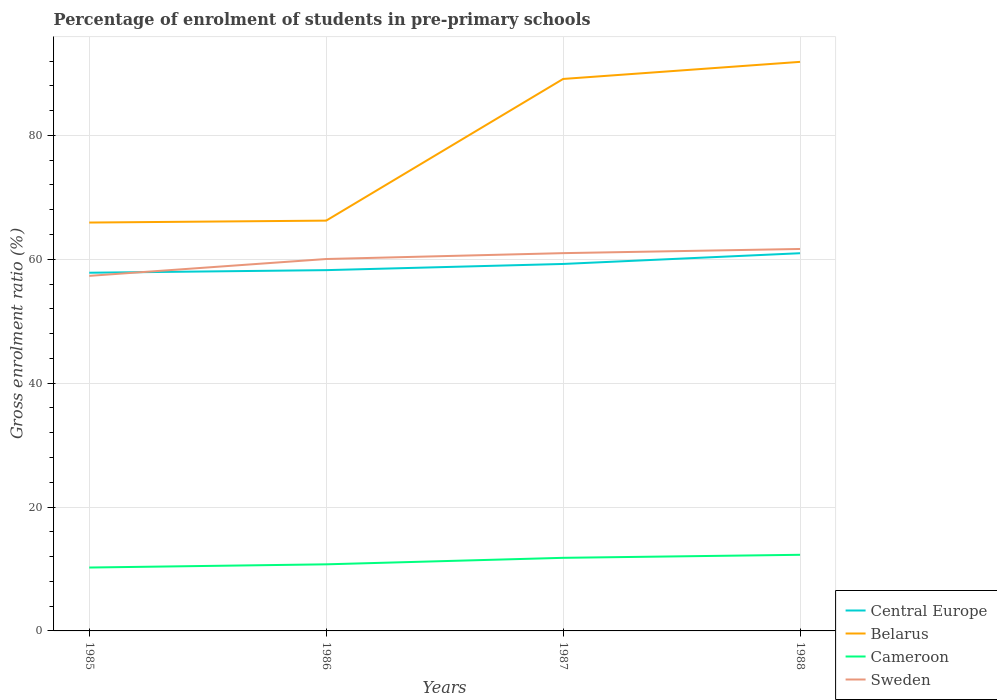How many different coloured lines are there?
Ensure brevity in your answer.  4. Does the line corresponding to Sweden intersect with the line corresponding to Cameroon?
Your answer should be compact. No. Is the number of lines equal to the number of legend labels?
Offer a very short reply. Yes. Across all years, what is the maximum percentage of students enrolled in pre-primary schools in Central Europe?
Your answer should be compact. 57.83. In which year was the percentage of students enrolled in pre-primary schools in Cameroon maximum?
Your answer should be compact. 1985. What is the total percentage of students enrolled in pre-primary schools in Cameroon in the graph?
Ensure brevity in your answer.  -1.54. What is the difference between the highest and the second highest percentage of students enrolled in pre-primary schools in Cameroon?
Keep it short and to the point. 2.06. What is the difference between the highest and the lowest percentage of students enrolled in pre-primary schools in Cameroon?
Give a very brief answer. 2. Is the percentage of students enrolled in pre-primary schools in Belarus strictly greater than the percentage of students enrolled in pre-primary schools in Sweden over the years?
Your answer should be very brief. No. How many years are there in the graph?
Offer a terse response. 4. What is the difference between two consecutive major ticks on the Y-axis?
Provide a succinct answer. 20. Does the graph contain any zero values?
Your answer should be very brief. No. How many legend labels are there?
Give a very brief answer. 4. How are the legend labels stacked?
Your response must be concise. Vertical. What is the title of the graph?
Your answer should be compact. Percentage of enrolment of students in pre-primary schools. Does "Japan" appear as one of the legend labels in the graph?
Ensure brevity in your answer.  No. What is the label or title of the X-axis?
Your answer should be compact. Years. What is the label or title of the Y-axis?
Provide a succinct answer. Gross enrolment ratio (%). What is the Gross enrolment ratio (%) in Central Europe in 1985?
Make the answer very short. 57.83. What is the Gross enrolment ratio (%) in Belarus in 1985?
Your answer should be very brief. 65.93. What is the Gross enrolment ratio (%) in Cameroon in 1985?
Provide a short and direct response. 10.23. What is the Gross enrolment ratio (%) of Sweden in 1985?
Ensure brevity in your answer.  57.32. What is the Gross enrolment ratio (%) in Central Europe in 1986?
Provide a short and direct response. 58.25. What is the Gross enrolment ratio (%) of Belarus in 1986?
Your response must be concise. 66.24. What is the Gross enrolment ratio (%) in Cameroon in 1986?
Your answer should be compact. 10.75. What is the Gross enrolment ratio (%) of Sweden in 1986?
Keep it short and to the point. 60.04. What is the Gross enrolment ratio (%) of Central Europe in 1987?
Your answer should be compact. 59.25. What is the Gross enrolment ratio (%) of Belarus in 1987?
Provide a succinct answer. 89.12. What is the Gross enrolment ratio (%) of Cameroon in 1987?
Make the answer very short. 11.8. What is the Gross enrolment ratio (%) of Sweden in 1987?
Provide a succinct answer. 60.99. What is the Gross enrolment ratio (%) of Central Europe in 1988?
Your answer should be compact. 60.98. What is the Gross enrolment ratio (%) in Belarus in 1988?
Give a very brief answer. 91.87. What is the Gross enrolment ratio (%) in Cameroon in 1988?
Your answer should be very brief. 12.29. What is the Gross enrolment ratio (%) in Sweden in 1988?
Your answer should be very brief. 61.67. Across all years, what is the maximum Gross enrolment ratio (%) of Central Europe?
Ensure brevity in your answer.  60.98. Across all years, what is the maximum Gross enrolment ratio (%) in Belarus?
Ensure brevity in your answer.  91.87. Across all years, what is the maximum Gross enrolment ratio (%) in Cameroon?
Ensure brevity in your answer.  12.29. Across all years, what is the maximum Gross enrolment ratio (%) in Sweden?
Make the answer very short. 61.67. Across all years, what is the minimum Gross enrolment ratio (%) of Central Europe?
Your answer should be very brief. 57.83. Across all years, what is the minimum Gross enrolment ratio (%) in Belarus?
Your response must be concise. 65.93. Across all years, what is the minimum Gross enrolment ratio (%) in Cameroon?
Provide a short and direct response. 10.23. Across all years, what is the minimum Gross enrolment ratio (%) of Sweden?
Your answer should be compact. 57.32. What is the total Gross enrolment ratio (%) of Central Europe in the graph?
Keep it short and to the point. 236.3. What is the total Gross enrolment ratio (%) in Belarus in the graph?
Provide a succinct answer. 313.16. What is the total Gross enrolment ratio (%) in Cameroon in the graph?
Ensure brevity in your answer.  45.08. What is the total Gross enrolment ratio (%) in Sweden in the graph?
Provide a succinct answer. 240.02. What is the difference between the Gross enrolment ratio (%) in Central Europe in 1985 and that in 1986?
Your answer should be very brief. -0.42. What is the difference between the Gross enrolment ratio (%) of Belarus in 1985 and that in 1986?
Provide a short and direct response. -0.31. What is the difference between the Gross enrolment ratio (%) in Cameroon in 1985 and that in 1986?
Make the answer very short. -0.52. What is the difference between the Gross enrolment ratio (%) of Sweden in 1985 and that in 1986?
Give a very brief answer. -2.72. What is the difference between the Gross enrolment ratio (%) in Central Europe in 1985 and that in 1987?
Your answer should be very brief. -1.42. What is the difference between the Gross enrolment ratio (%) of Belarus in 1985 and that in 1987?
Your answer should be very brief. -23.18. What is the difference between the Gross enrolment ratio (%) of Cameroon in 1985 and that in 1987?
Offer a very short reply. -1.57. What is the difference between the Gross enrolment ratio (%) of Sweden in 1985 and that in 1987?
Provide a succinct answer. -3.67. What is the difference between the Gross enrolment ratio (%) in Central Europe in 1985 and that in 1988?
Make the answer very short. -3.15. What is the difference between the Gross enrolment ratio (%) of Belarus in 1985 and that in 1988?
Give a very brief answer. -25.94. What is the difference between the Gross enrolment ratio (%) of Cameroon in 1985 and that in 1988?
Your answer should be very brief. -2.06. What is the difference between the Gross enrolment ratio (%) in Sweden in 1985 and that in 1988?
Make the answer very short. -4.34. What is the difference between the Gross enrolment ratio (%) in Central Europe in 1986 and that in 1987?
Offer a very short reply. -1. What is the difference between the Gross enrolment ratio (%) in Belarus in 1986 and that in 1987?
Give a very brief answer. -22.87. What is the difference between the Gross enrolment ratio (%) in Cameroon in 1986 and that in 1987?
Make the answer very short. -1.05. What is the difference between the Gross enrolment ratio (%) of Sweden in 1986 and that in 1987?
Ensure brevity in your answer.  -0.95. What is the difference between the Gross enrolment ratio (%) in Central Europe in 1986 and that in 1988?
Offer a terse response. -2.73. What is the difference between the Gross enrolment ratio (%) of Belarus in 1986 and that in 1988?
Make the answer very short. -25.63. What is the difference between the Gross enrolment ratio (%) of Cameroon in 1986 and that in 1988?
Make the answer very short. -1.54. What is the difference between the Gross enrolment ratio (%) of Sweden in 1986 and that in 1988?
Give a very brief answer. -1.62. What is the difference between the Gross enrolment ratio (%) of Central Europe in 1987 and that in 1988?
Provide a short and direct response. -1.73. What is the difference between the Gross enrolment ratio (%) in Belarus in 1987 and that in 1988?
Your answer should be compact. -2.76. What is the difference between the Gross enrolment ratio (%) of Cameroon in 1987 and that in 1988?
Offer a terse response. -0.49. What is the difference between the Gross enrolment ratio (%) of Sweden in 1987 and that in 1988?
Offer a very short reply. -0.67. What is the difference between the Gross enrolment ratio (%) of Central Europe in 1985 and the Gross enrolment ratio (%) of Belarus in 1986?
Make the answer very short. -8.41. What is the difference between the Gross enrolment ratio (%) of Central Europe in 1985 and the Gross enrolment ratio (%) of Cameroon in 1986?
Your answer should be compact. 47.08. What is the difference between the Gross enrolment ratio (%) of Central Europe in 1985 and the Gross enrolment ratio (%) of Sweden in 1986?
Offer a very short reply. -2.21. What is the difference between the Gross enrolment ratio (%) of Belarus in 1985 and the Gross enrolment ratio (%) of Cameroon in 1986?
Make the answer very short. 55.18. What is the difference between the Gross enrolment ratio (%) in Belarus in 1985 and the Gross enrolment ratio (%) in Sweden in 1986?
Offer a terse response. 5.89. What is the difference between the Gross enrolment ratio (%) of Cameroon in 1985 and the Gross enrolment ratio (%) of Sweden in 1986?
Offer a terse response. -49.81. What is the difference between the Gross enrolment ratio (%) in Central Europe in 1985 and the Gross enrolment ratio (%) in Belarus in 1987?
Provide a succinct answer. -31.29. What is the difference between the Gross enrolment ratio (%) of Central Europe in 1985 and the Gross enrolment ratio (%) of Cameroon in 1987?
Provide a short and direct response. 46.03. What is the difference between the Gross enrolment ratio (%) in Central Europe in 1985 and the Gross enrolment ratio (%) in Sweden in 1987?
Your response must be concise. -3.16. What is the difference between the Gross enrolment ratio (%) in Belarus in 1985 and the Gross enrolment ratio (%) in Cameroon in 1987?
Offer a very short reply. 54.13. What is the difference between the Gross enrolment ratio (%) in Belarus in 1985 and the Gross enrolment ratio (%) in Sweden in 1987?
Offer a very short reply. 4.94. What is the difference between the Gross enrolment ratio (%) in Cameroon in 1985 and the Gross enrolment ratio (%) in Sweden in 1987?
Offer a very short reply. -50.76. What is the difference between the Gross enrolment ratio (%) of Central Europe in 1985 and the Gross enrolment ratio (%) of Belarus in 1988?
Offer a terse response. -34.04. What is the difference between the Gross enrolment ratio (%) of Central Europe in 1985 and the Gross enrolment ratio (%) of Cameroon in 1988?
Your response must be concise. 45.54. What is the difference between the Gross enrolment ratio (%) in Central Europe in 1985 and the Gross enrolment ratio (%) in Sweden in 1988?
Provide a short and direct response. -3.84. What is the difference between the Gross enrolment ratio (%) of Belarus in 1985 and the Gross enrolment ratio (%) of Cameroon in 1988?
Give a very brief answer. 53.64. What is the difference between the Gross enrolment ratio (%) of Belarus in 1985 and the Gross enrolment ratio (%) of Sweden in 1988?
Your answer should be very brief. 4.27. What is the difference between the Gross enrolment ratio (%) in Cameroon in 1985 and the Gross enrolment ratio (%) in Sweden in 1988?
Give a very brief answer. -51.43. What is the difference between the Gross enrolment ratio (%) in Central Europe in 1986 and the Gross enrolment ratio (%) in Belarus in 1987?
Your answer should be very brief. -30.87. What is the difference between the Gross enrolment ratio (%) of Central Europe in 1986 and the Gross enrolment ratio (%) of Cameroon in 1987?
Your answer should be very brief. 46.45. What is the difference between the Gross enrolment ratio (%) of Central Europe in 1986 and the Gross enrolment ratio (%) of Sweden in 1987?
Provide a short and direct response. -2.74. What is the difference between the Gross enrolment ratio (%) in Belarus in 1986 and the Gross enrolment ratio (%) in Cameroon in 1987?
Offer a terse response. 54.44. What is the difference between the Gross enrolment ratio (%) of Belarus in 1986 and the Gross enrolment ratio (%) of Sweden in 1987?
Ensure brevity in your answer.  5.25. What is the difference between the Gross enrolment ratio (%) of Cameroon in 1986 and the Gross enrolment ratio (%) of Sweden in 1987?
Give a very brief answer. -50.24. What is the difference between the Gross enrolment ratio (%) in Central Europe in 1986 and the Gross enrolment ratio (%) in Belarus in 1988?
Offer a very short reply. -33.63. What is the difference between the Gross enrolment ratio (%) in Central Europe in 1986 and the Gross enrolment ratio (%) in Cameroon in 1988?
Your response must be concise. 45.96. What is the difference between the Gross enrolment ratio (%) in Central Europe in 1986 and the Gross enrolment ratio (%) in Sweden in 1988?
Give a very brief answer. -3.42. What is the difference between the Gross enrolment ratio (%) in Belarus in 1986 and the Gross enrolment ratio (%) in Cameroon in 1988?
Make the answer very short. 53.95. What is the difference between the Gross enrolment ratio (%) of Belarus in 1986 and the Gross enrolment ratio (%) of Sweden in 1988?
Make the answer very short. 4.58. What is the difference between the Gross enrolment ratio (%) in Cameroon in 1986 and the Gross enrolment ratio (%) in Sweden in 1988?
Keep it short and to the point. -50.91. What is the difference between the Gross enrolment ratio (%) of Central Europe in 1987 and the Gross enrolment ratio (%) of Belarus in 1988?
Give a very brief answer. -32.63. What is the difference between the Gross enrolment ratio (%) in Central Europe in 1987 and the Gross enrolment ratio (%) in Cameroon in 1988?
Keep it short and to the point. 46.95. What is the difference between the Gross enrolment ratio (%) of Central Europe in 1987 and the Gross enrolment ratio (%) of Sweden in 1988?
Keep it short and to the point. -2.42. What is the difference between the Gross enrolment ratio (%) in Belarus in 1987 and the Gross enrolment ratio (%) in Cameroon in 1988?
Offer a terse response. 76.82. What is the difference between the Gross enrolment ratio (%) of Belarus in 1987 and the Gross enrolment ratio (%) of Sweden in 1988?
Offer a terse response. 27.45. What is the difference between the Gross enrolment ratio (%) in Cameroon in 1987 and the Gross enrolment ratio (%) in Sweden in 1988?
Ensure brevity in your answer.  -49.87. What is the average Gross enrolment ratio (%) in Central Europe per year?
Your answer should be compact. 59.08. What is the average Gross enrolment ratio (%) in Belarus per year?
Your answer should be very brief. 78.29. What is the average Gross enrolment ratio (%) in Cameroon per year?
Offer a very short reply. 11.27. What is the average Gross enrolment ratio (%) in Sweden per year?
Your response must be concise. 60.01. In the year 1985, what is the difference between the Gross enrolment ratio (%) of Central Europe and Gross enrolment ratio (%) of Belarus?
Provide a succinct answer. -8.1. In the year 1985, what is the difference between the Gross enrolment ratio (%) of Central Europe and Gross enrolment ratio (%) of Cameroon?
Your answer should be very brief. 47.6. In the year 1985, what is the difference between the Gross enrolment ratio (%) of Central Europe and Gross enrolment ratio (%) of Sweden?
Keep it short and to the point. 0.51. In the year 1985, what is the difference between the Gross enrolment ratio (%) in Belarus and Gross enrolment ratio (%) in Cameroon?
Provide a succinct answer. 55.7. In the year 1985, what is the difference between the Gross enrolment ratio (%) of Belarus and Gross enrolment ratio (%) of Sweden?
Ensure brevity in your answer.  8.61. In the year 1985, what is the difference between the Gross enrolment ratio (%) in Cameroon and Gross enrolment ratio (%) in Sweden?
Give a very brief answer. -47.09. In the year 1986, what is the difference between the Gross enrolment ratio (%) of Central Europe and Gross enrolment ratio (%) of Belarus?
Provide a succinct answer. -7.99. In the year 1986, what is the difference between the Gross enrolment ratio (%) of Central Europe and Gross enrolment ratio (%) of Cameroon?
Make the answer very short. 47.5. In the year 1986, what is the difference between the Gross enrolment ratio (%) in Central Europe and Gross enrolment ratio (%) in Sweden?
Your answer should be very brief. -1.8. In the year 1986, what is the difference between the Gross enrolment ratio (%) of Belarus and Gross enrolment ratio (%) of Cameroon?
Offer a very short reply. 55.49. In the year 1986, what is the difference between the Gross enrolment ratio (%) of Belarus and Gross enrolment ratio (%) of Sweden?
Provide a succinct answer. 6.2. In the year 1986, what is the difference between the Gross enrolment ratio (%) in Cameroon and Gross enrolment ratio (%) in Sweden?
Make the answer very short. -49.29. In the year 1987, what is the difference between the Gross enrolment ratio (%) of Central Europe and Gross enrolment ratio (%) of Belarus?
Offer a very short reply. -29.87. In the year 1987, what is the difference between the Gross enrolment ratio (%) in Central Europe and Gross enrolment ratio (%) in Cameroon?
Provide a succinct answer. 47.45. In the year 1987, what is the difference between the Gross enrolment ratio (%) of Central Europe and Gross enrolment ratio (%) of Sweden?
Provide a short and direct response. -1.75. In the year 1987, what is the difference between the Gross enrolment ratio (%) of Belarus and Gross enrolment ratio (%) of Cameroon?
Offer a very short reply. 77.31. In the year 1987, what is the difference between the Gross enrolment ratio (%) of Belarus and Gross enrolment ratio (%) of Sweden?
Your answer should be very brief. 28.12. In the year 1987, what is the difference between the Gross enrolment ratio (%) in Cameroon and Gross enrolment ratio (%) in Sweden?
Your response must be concise. -49.19. In the year 1988, what is the difference between the Gross enrolment ratio (%) of Central Europe and Gross enrolment ratio (%) of Belarus?
Give a very brief answer. -30.89. In the year 1988, what is the difference between the Gross enrolment ratio (%) of Central Europe and Gross enrolment ratio (%) of Cameroon?
Offer a terse response. 48.69. In the year 1988, what is the difference between the Gross enrolment ratio (%) in Central Europe and Gross enrolment ratio (%) in Sweden?
Your answer should be compact. -0.69. In the year 1988, what is the difference between the Gross enrolment ratio (%) in Belarus and Gross enrolment ratio (%) in Cameroon?
Your response must be concise. 79.58. In the year 1988, what is the difference between the Gross enrolment ratio (%) in Belarus and Gross enrolment ratio (%) in Sweden?
Offer a terse response. 30.21. In the year 1988, what is the difference between the Gross enrolment ratio (%) of Cameroon and Gross enrolment ratio (%) of Sweden?
Keep it short and to the point. -49.37. What is the ratio of the Gross enrolment ratio (%) of Central Europe in 1985 to that in 1986?
Keep it short and to the point. 0.99. What is the ratio of the Gross enrolment ratio (%) in Cameroon in 1985 to that in 1986?
Provide a short and direct response. 0.95. What is the ratio of the Gross enrolment ratio (%) in Sweden in 1985 to that in 1986?
Provide a succinct answer. 0.95. What is the ratio of the Gross enrolment ratio (%) in Central Europe in 1985 to that in 1987?
Keep it short and to the point. 0.98. What is the ratio of the Gross enrolment ratio (%) of Belarus in 1985 to that in 1987?
Your answer should be very brief. 0.74. What is the ratio of the Gross enrolment ratio (%) of Cameroon in 1985 to that in 1987?
Give a very brief answer. 0.87. What is the ratio of the Gross enrolment ratio (%) of Sweden in 1985 to that in 1987?
Ensure brevity in your answer.  0.94. What is the ratio of the Gross enrolment ratio (%) of Central Europe in 1985 to that in 1988?
Offer a very short reply. 0.95. What is the ratio of the Gross enrolment ratio (%) in Belarus in 1985 to that in 1988?
Ensure brevity in your answer.  0.72. What is the ratio of the Gross enrolment ratio (%) of Cameroon in 1985 to that in 1988?
Provide a succinct answer. 0.83. What is the ratio of the Gross enrolment ratio (%) in Sweden in 1985 to that in 1988?
Offer a terse response. 0.93. What is the ratio of the Gross enrolment ratio (%) of Central Europe in 1986 to that in 1987?
Give a very brief answer. 0.98. What is the ratio of the Gross enrolment ratio (%) of Belarus in 1986 to that in 1987?
Provide a short and direct response. 0.74. What is the ratio of the Gross enrolment ratio (%) in Cameroon in 1986 to that in 1987?
Your response must be concise. 0.91. What is the ratio of the Gross enrolment ratio (%) of Sweden in 1986 to that in 1987?
Make the answer very short. 0.98. What is the ratio of the Gross enrolment ratio (%) in Central Europe in 1986 to that in 1988?
Provide a short and direct response. 0.96. What is the ratio of the Gross enrolment ratio (%) in Belarus in 1986 to that in 1988?
Your answer should be very brief. 0.72. What is the ratio of the Gross enrolment ratio (%) of Cameroon in 1986 to that in 1988?
Give a very brief answer. 0.87. What is the ratio of the Gross enrolment ratio (%) of Sweden in 1986 to that in 1988?
Make the answer very short. 0.97. What is the ratio of the Gross enrolment ratio (%) in Central Europe in 1987 to that in 1988?
Provide a short and direct response. 0.97. What is the ratio of the Gross enrolment ratio (%) in Belarus in 1987 to that in 1988?
Your response must be concise. 0.97. What is the ratio of the Gross enrolment ratio (%) in Cameroon in 1987 to that in 1988?
Make the answer very short. 0.96. What is the ratio of the Gross enrolment ratio (%) in Sweden in 1987 to that in 1988?
Make the answer very short. 0.99. What is the difference between the highest and the second highest Gross enrolment ratio (%) of Central Europe?
Keep it short and to the point. 1.73. What is the difference between the highest and the second highest Gross enrolment ratio (%) of Belarus?
Your answer should be compact. 2.76. What is the difference between the highest and the second highest Gross enrolment ratio (%) in Cameroon?
Make the answer very short. 0.49. What is the difference between the highest and the second highest Gross enrolment ratio (%) in Sweden?
Your response must be concise. 0.67. What is the difference between the highest and the lowest Gross enrolment ratio (%) in Central Europe?
Offer a very short reply. 3.15. What is the difference between the highest and the lowest Gross enrolment ratio (%) of Belarus?
Your response must be concise. 25.94. What is the difference between the highest and the lowest Gross enrolment ratio (%) in Cameroon?
Your answer should be compact. 2.06. What is the difference between the highest and the lowest Gross enrolment ratio (%) of Sweden?
Provide a short and direct response. 4.34. 